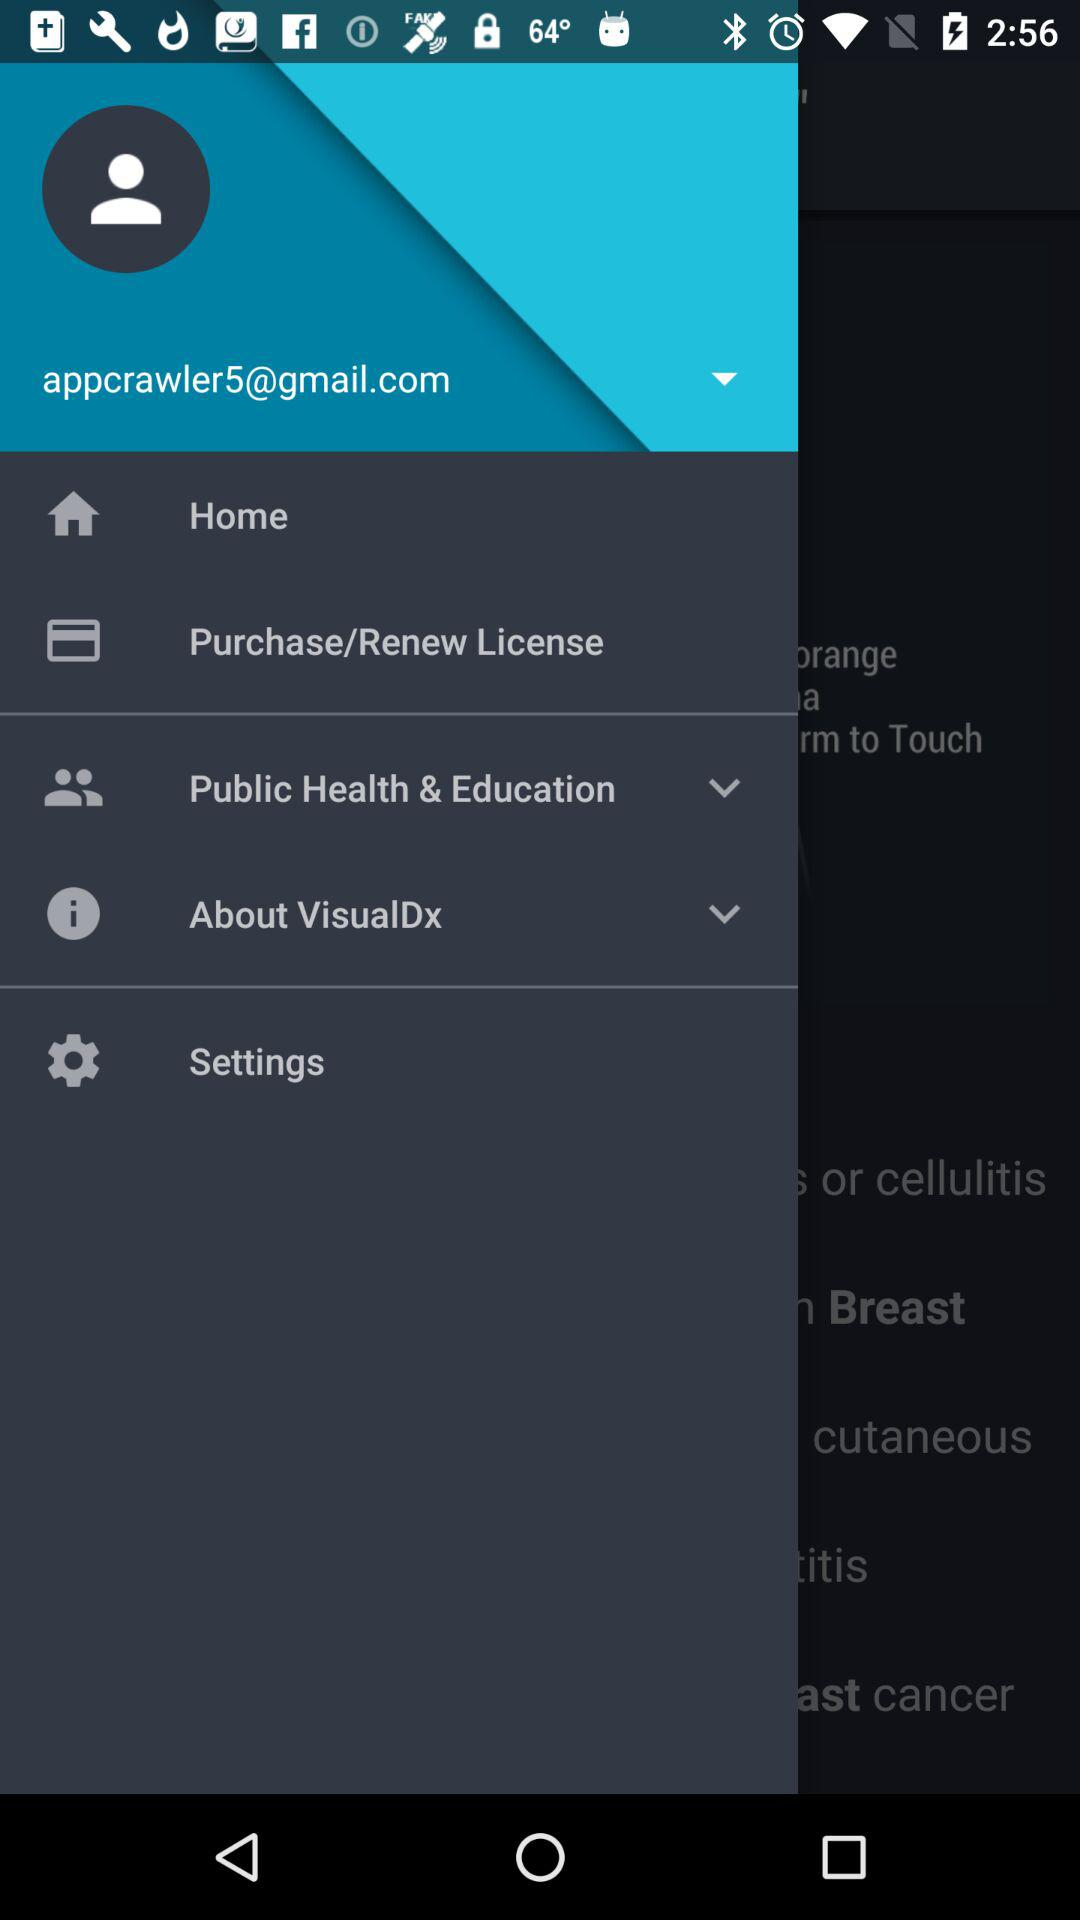How many notifications are there in "Settings"?
When the provided information is insufficient, respond with <no answer>. <no answer> 